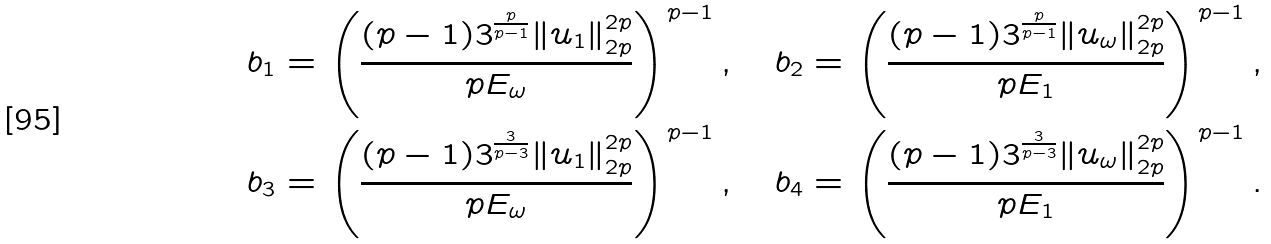Convert formula to latex. <formula><loc_0><loc_0><loc_500><loc_500>& b _ { 1 } = \left ( \frac { ( p - 1 ) 3 ^ { \frac { p } { p - 1 } } \| u _ { 1 } \| _ { 2 p } ^ { 2 p } } { p E _ { \omega } } \right ) ^ { p - 1 } , \quad b _ { 2 } = \left ( \frac { ( p - 1 ) 3 ^ { \frac { p } { p - 1 } } \| u _ { \omega } \| _ { 2 p } ^ { 2 p } } { p E _ { 1 } } \right ) ^ { p - 1 } , \\ & b _ { 3 } = \left ( \frac { ( p - 1 ) 3 ^ { \frac { 3 } { p - 3 } } \| u _ { 1 } \| _ { 2 p } ^ { 2 p } } { p E _ { \omega } } \right ) ^ { p - 1 } , \quad b _ { 4 } = \left ( \frac { ( p - 1 ) 3 ^ { \frac { 3 } { p - 3 } } \| u _ { \omega } \| _ { 2 p } ^ { 2 p } } { p E _ { 1 } } \right ) ^ { p - 1 } .</formula> 